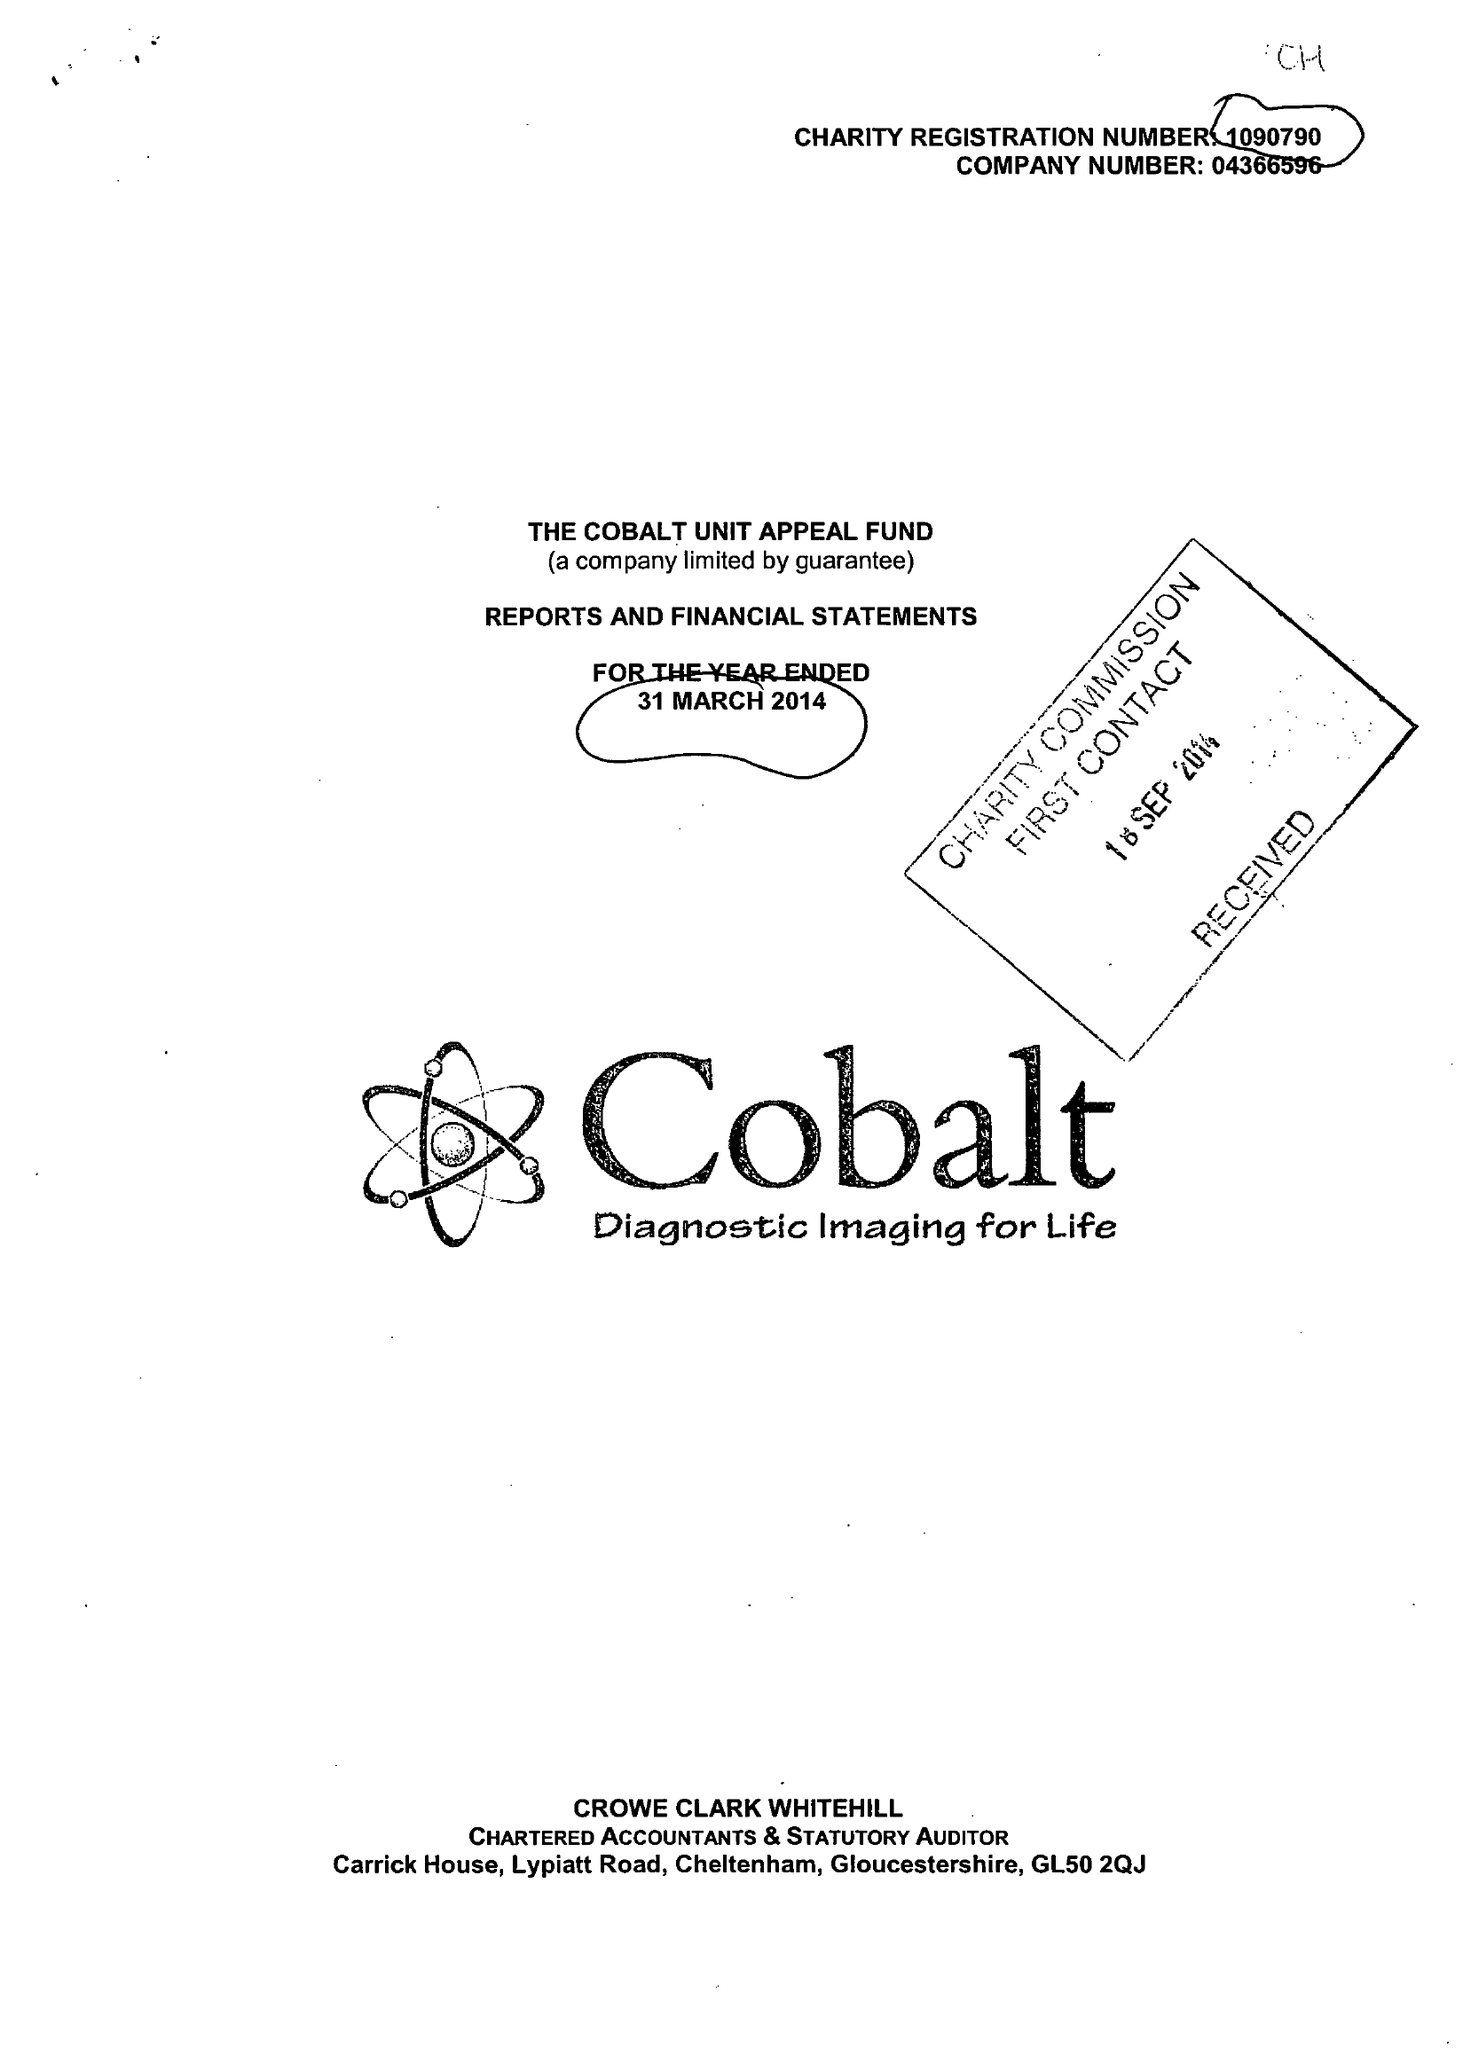What is the value for the charity_name?
Answer the question using a single word or phrase. Cobalt Health 